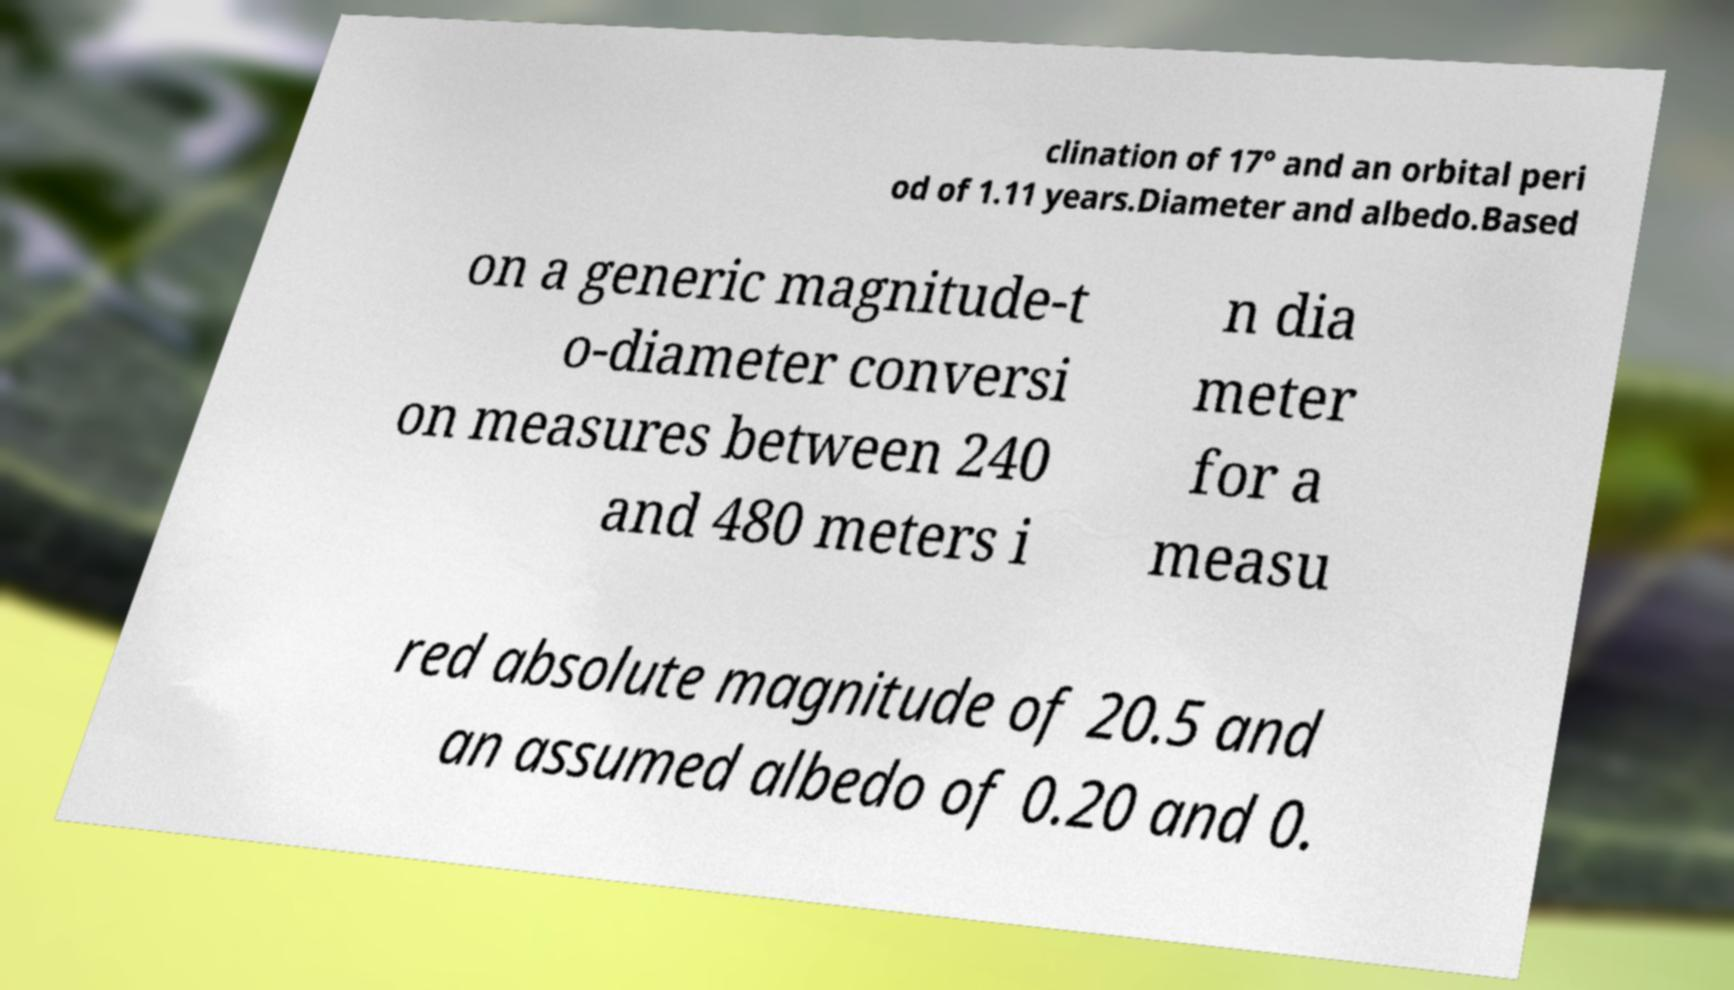There's text embedded in this image that I need extracted. Can you transcribe it verbatim? clination of 17° and an orbital peri od of 1.11 years.Diameter and albedo.Based on a generic magnitude-t o-diameter conversi on measures between 240 and 480 meters i n dia meter for a measu red absolute magnitude of 20.5 and an assumed albedo of 0.20 and 0. 